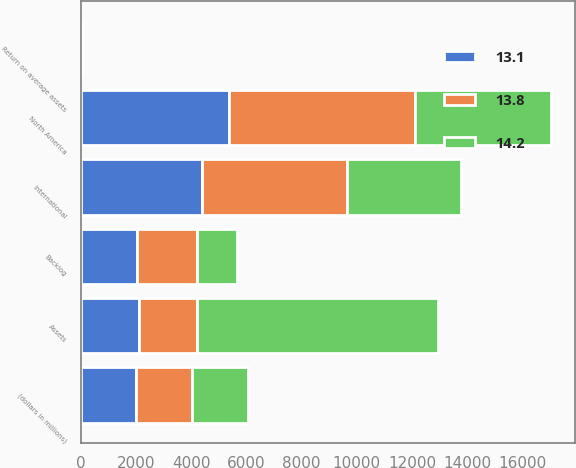Convert chart to OTSL. <chart><loc_0><loc_0><loc_500><loc_500><stacked_bar_chart><ecel><fcel>(dollars in millions)<fcel>North America<fcel>International<fcel>Backlog<fcel>Assets<fcel>Return on average assets<nl><fcel>13.8<fcel>2018<fcel>6727<fcel>5260<fcel>2167<fcel>2104<fcel>13.8<nl><fcel>13.1<fcel>2017<fcel>5367<fcel>4378<fcel>2041<fcel>2104<fcel>13.1<nl><fcel>14.2<fcel>2016<fcel>4955<fcel>4145<fcel>1455<fcel>8729<fcel>14.2<nl></chart> 